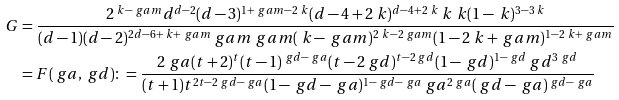Convert formula to latex. <formula><loc_0><loc_0><loc_500><loc_500>G & = \frac { 2 ^ { \ k - \ g a m } d ^ { d - 2 } ( d - 3 ) ^ { 1 + \ g a m - 2 \ k } ( d - 4 + 2 \ k ) ^ { d - 4 + 2 \ k } \ k ^ { \ } k ( 1 - \ k ) ^ { 3 - 3 \ k } } { ( d - 1 ) ( d - 2 ) ^ { 2 d - 6 + \ k + \ g a m } \ g a m ^ { \ } g a m ( \ k - \ g a m ) ^ { 2 \ k - 2 \ g a m } ( 1 - 2 \ k + \ g a m ) ^ { 1 - 2 \ k + \ g a m } } \\ & = F ( \ g a , \ g d ) \colon = \frac { 2 ^ { \ } g a ( t + 2 ) ^ { t } ( t - 1 ) ^ { \ g d - \ g a } ( t - 2 \ g d ) ^ { t - 2 \ g d } ( 1 - \ g d ) ^ { 1 - \ g d } \ g d ^ { 3 \ g d } } { ( t + 1 ) t ^ { 2 t - 2 \ g d - \ g a } ( 1 - \ g d - \ g a ) ^ { 1 - \ g d - \ g a } \ g a ^ { 2 \ g a } ( \ g d - \ g a ) ^ { \ g d - \ g a } }</formula> 